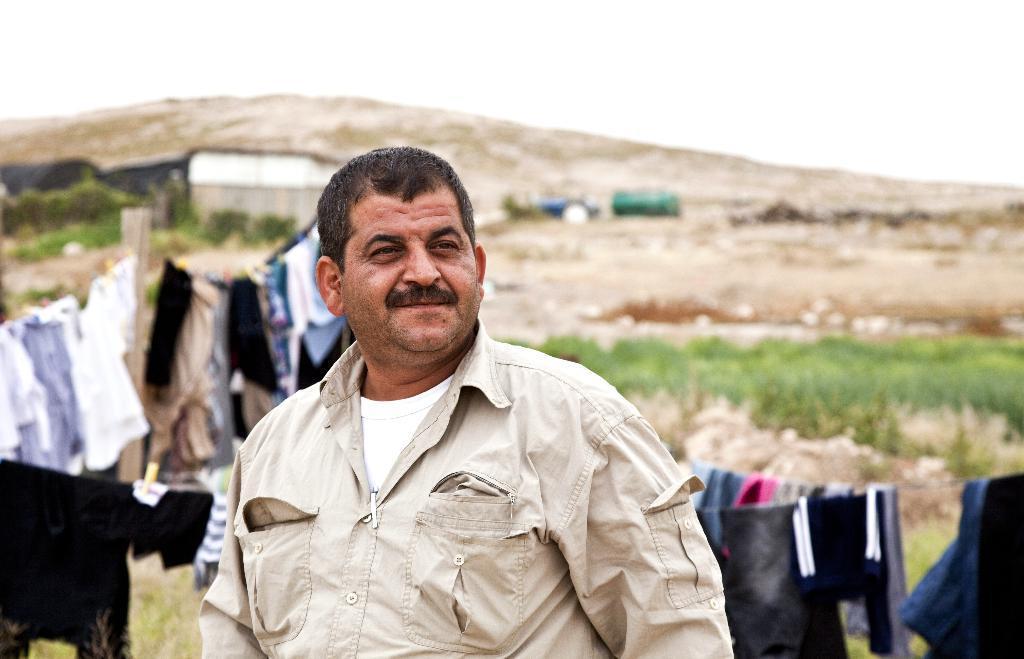In one or two sentences, can you explain what this image depicts? This is the man standing and smiling. He wore a shirt. These are the clothes hanging on the ropes. In the background, I can see a hill, house, and trees. 